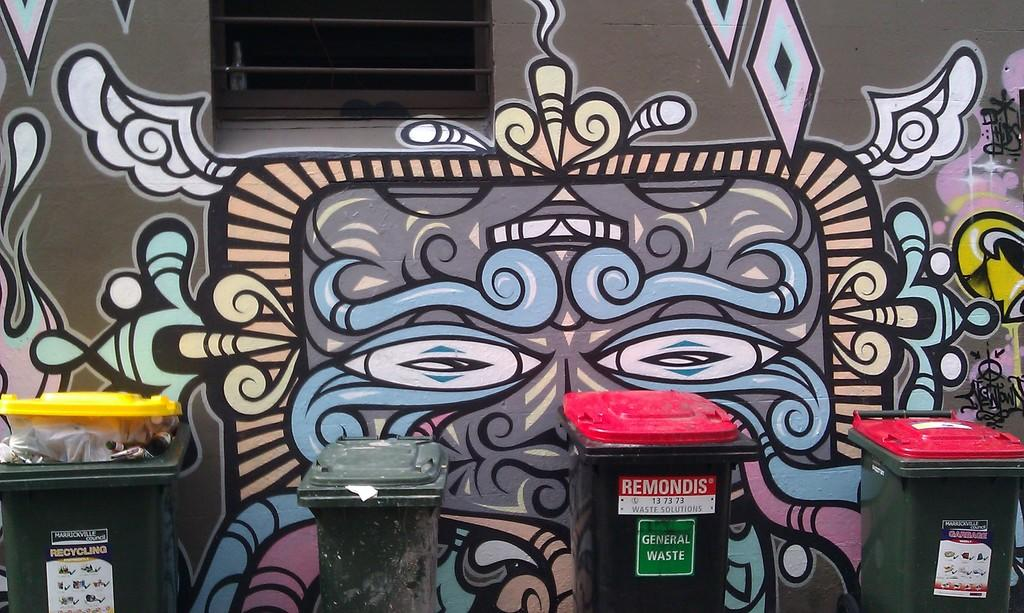<image>
Offer a succinct explanation of the picture presented. A recycling bin, general waste bin, garbage bin and an unmarked bin in front of a wall mural. 